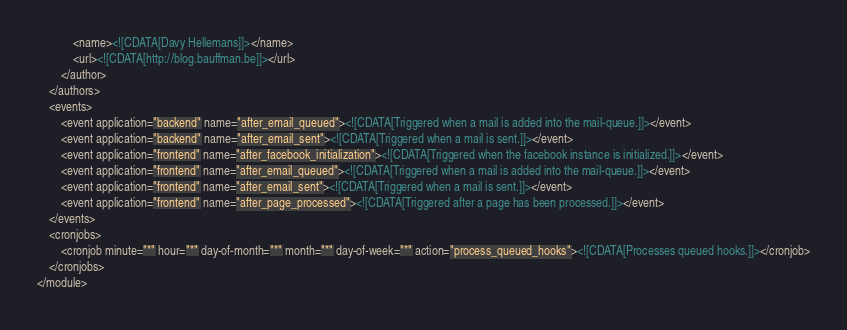Convert code to text. <code><loc_0><loc_0><loc_500><loc_500><_XML_>			<name><![CDATA[Davy Hellemans]]></name>
			<url><![CDATA[http://blog.bauffman.be]]></url>
		</author>
	</authors>
	<events>
		<event application="backend" name="after_email_queued"><![CDATA[Triggered when a mail is added into the mail-queue.]]></event>
		<event application="backend" name="after_email_sent"><![CDATA[Triggered when a mail is sent.]]></event>
		<event application="frontend" name="after_facebook_initialization"><![CDATA[Triggered when the facebook instance is initialized.]]></event>
		<event application="frontend" name="after_email_queued"><![CDATA[Triggered when a mail is added into the mail-queue.]]></event>
		<event application="frontend" name="after_email_sent"><![CDATA[Triggered when a mail is sent.]]></event>
		<event application="frontend" name="after_page_processed"><![CDATA[Triggered after a page has been processed.]]></event>
	</events>
	<cronjobs>
		<cronjob minute="*" hour="*" day-of-month="*" month="*" day-of-week="*" action="process_queued_hooks"><![CDATA[Processes queued hooks.]]></cronjob>
	</cronjobs>
</module>
</code> 